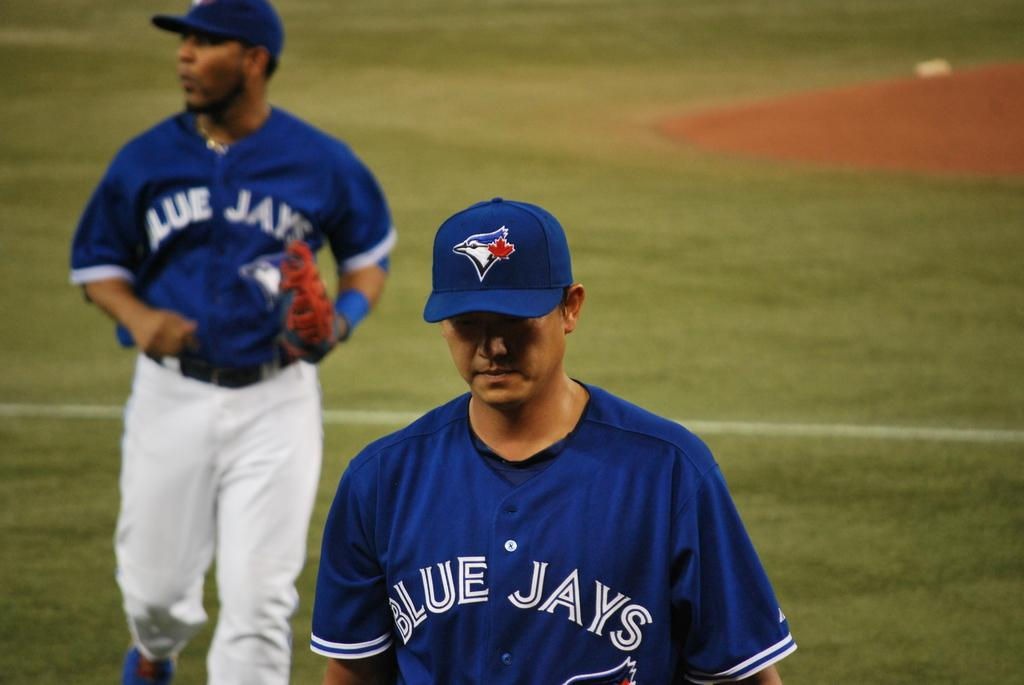<image>
Offer a succinct explanation of the picture presented. Two Blue Jays players are on the baseball field during a game. 